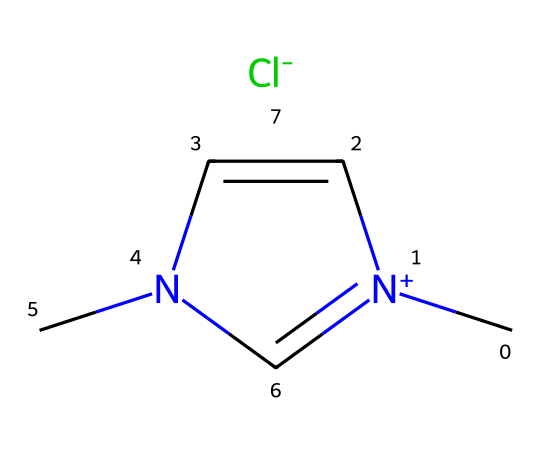What is the central atom in this imidazolium-based ionic liquid? The central atom in this chemical structure is the nitrogen atom, which is part of the imidazolium ring that plays a crucial role in ionic liquids.
Answer: nitrogen How many nitrogen atoms are present in this structure? The chemical structure shows two nitrogen atoms located in the imidazolium ring of the ionic liquid.
Answer: two What type of ion is represented by [Cl-] in this ionic liquid? The [Cl-] represents a chloride ion, which is the anion paired with the imidazolium cation in this ionic liquid.
Answer: chloride What is the overall charge of the imidazolium ion in the structure? The imidazolium ion carries a positive charge, as indicated by the notation [n+], which denotes that it is a cation.
Answer: positive What property of ionic liquids is exhibited by the presence of both cation and anion in this structure? The combination of a cation (imidazolium) and an anion (chloride) illustrates the characteristic feature of ionic liquids, which is their ionic nature that allows for tunable properties.
Answer: ionic nature What role does this imidazolium-based ionic liquid play in the extraction of Omani frankincense? This ionic liquid serves as a solvent that enhances the extraction efficiency and selectivity for compounds from Omani frankincense due to its unique solvation properties.
Answer: solvent 